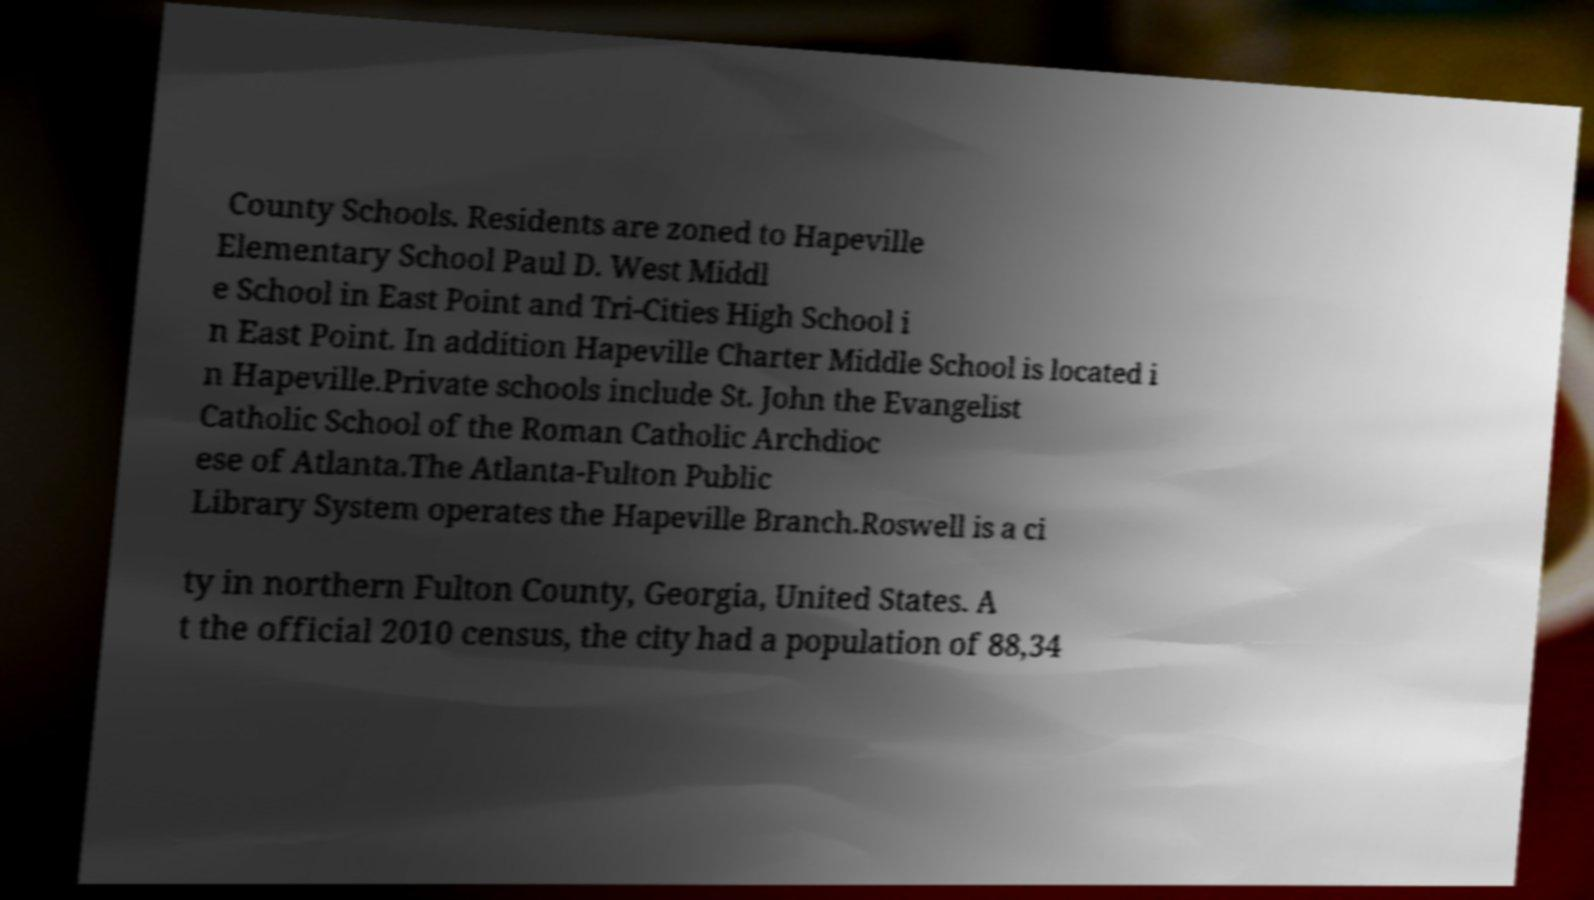Could you extract and type out the text from this image? County Schools. Residents are zoned to Hapeville Elementary School Paul D. West Middl e School in East Point and Tri-Cities High School i n East Point. In addition Hapeville Charter Middle School is located i n Hapeville.Private schools include St. John the Evangelist Catholic School of the Roman Catholic Archdioc ese of Atlanta.The Atlanta-Fulton Public Library System operates the Hapeville Branch.Roswell is a ci ty in northern Fulton County, Georgia, United States. A t the official 2010 census, the city had a population of 88,34 